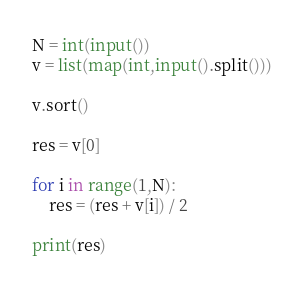Convert code to text. <code><loc_0><loc_0><loc_500><loc_500><_Python_>N = int(input())
v = list(map(int,input().split()))

v.sort()

res = v[0]

for i in range(1,N):
    res = (res + v[i]) / 2 

print(res)

</code> 